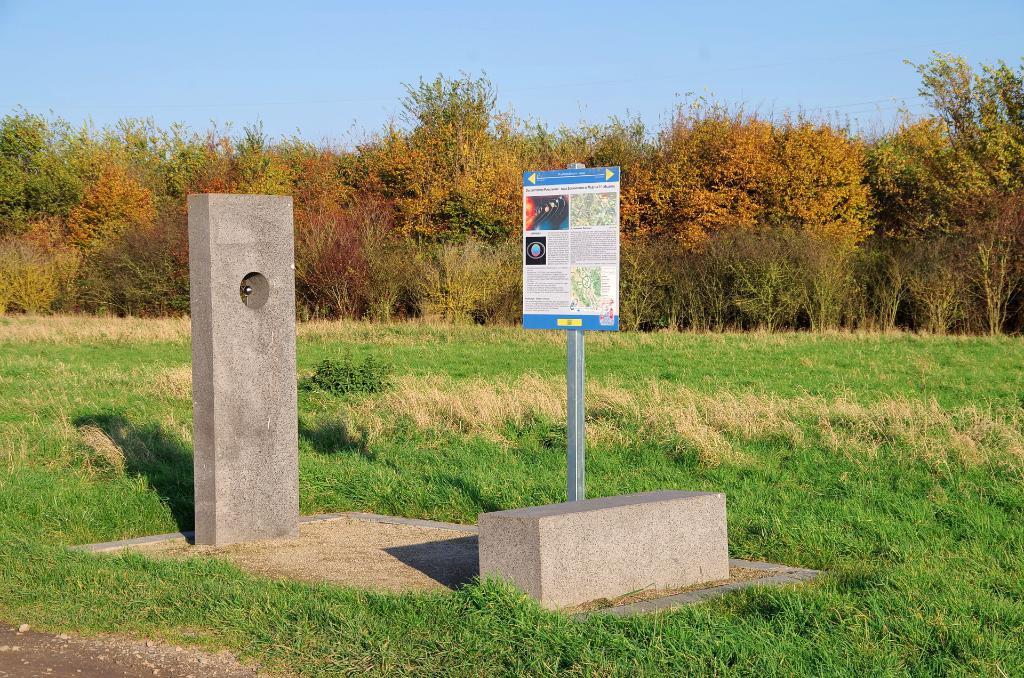Describe this image in one or two sentences. In this image there is a board to a pole. There is text on the board. Beside the board there is a small pillar. There is grass on the ground. In the background there are trees and plants. At the top there is the sky. 